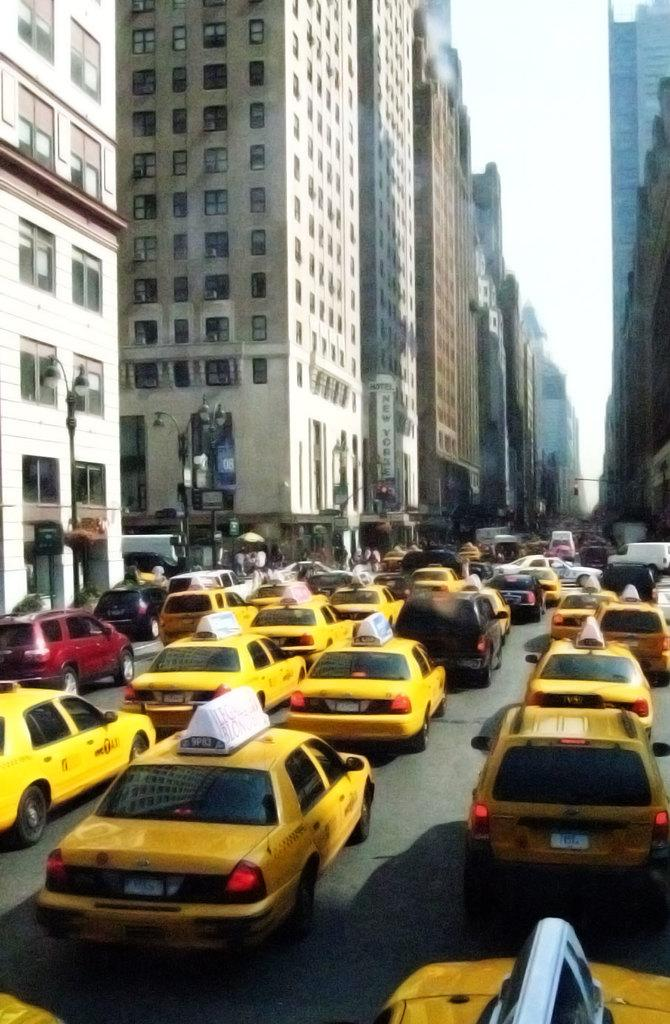What can be seen on the road in the image? There are vehicles on the road in the image. What structures are present alongside the road? There are light poles in the image. What type of buildings can be seen in the image? There are buildings with windows in the image. What is visible in the background of the image? The sky is visible in the background of the image. Can you see a cap on the head of the achiever in the image? There is no mention of a cap or an achiever in the image; it features vehicles on the road, light poles, buildings with windows, and the sky. 